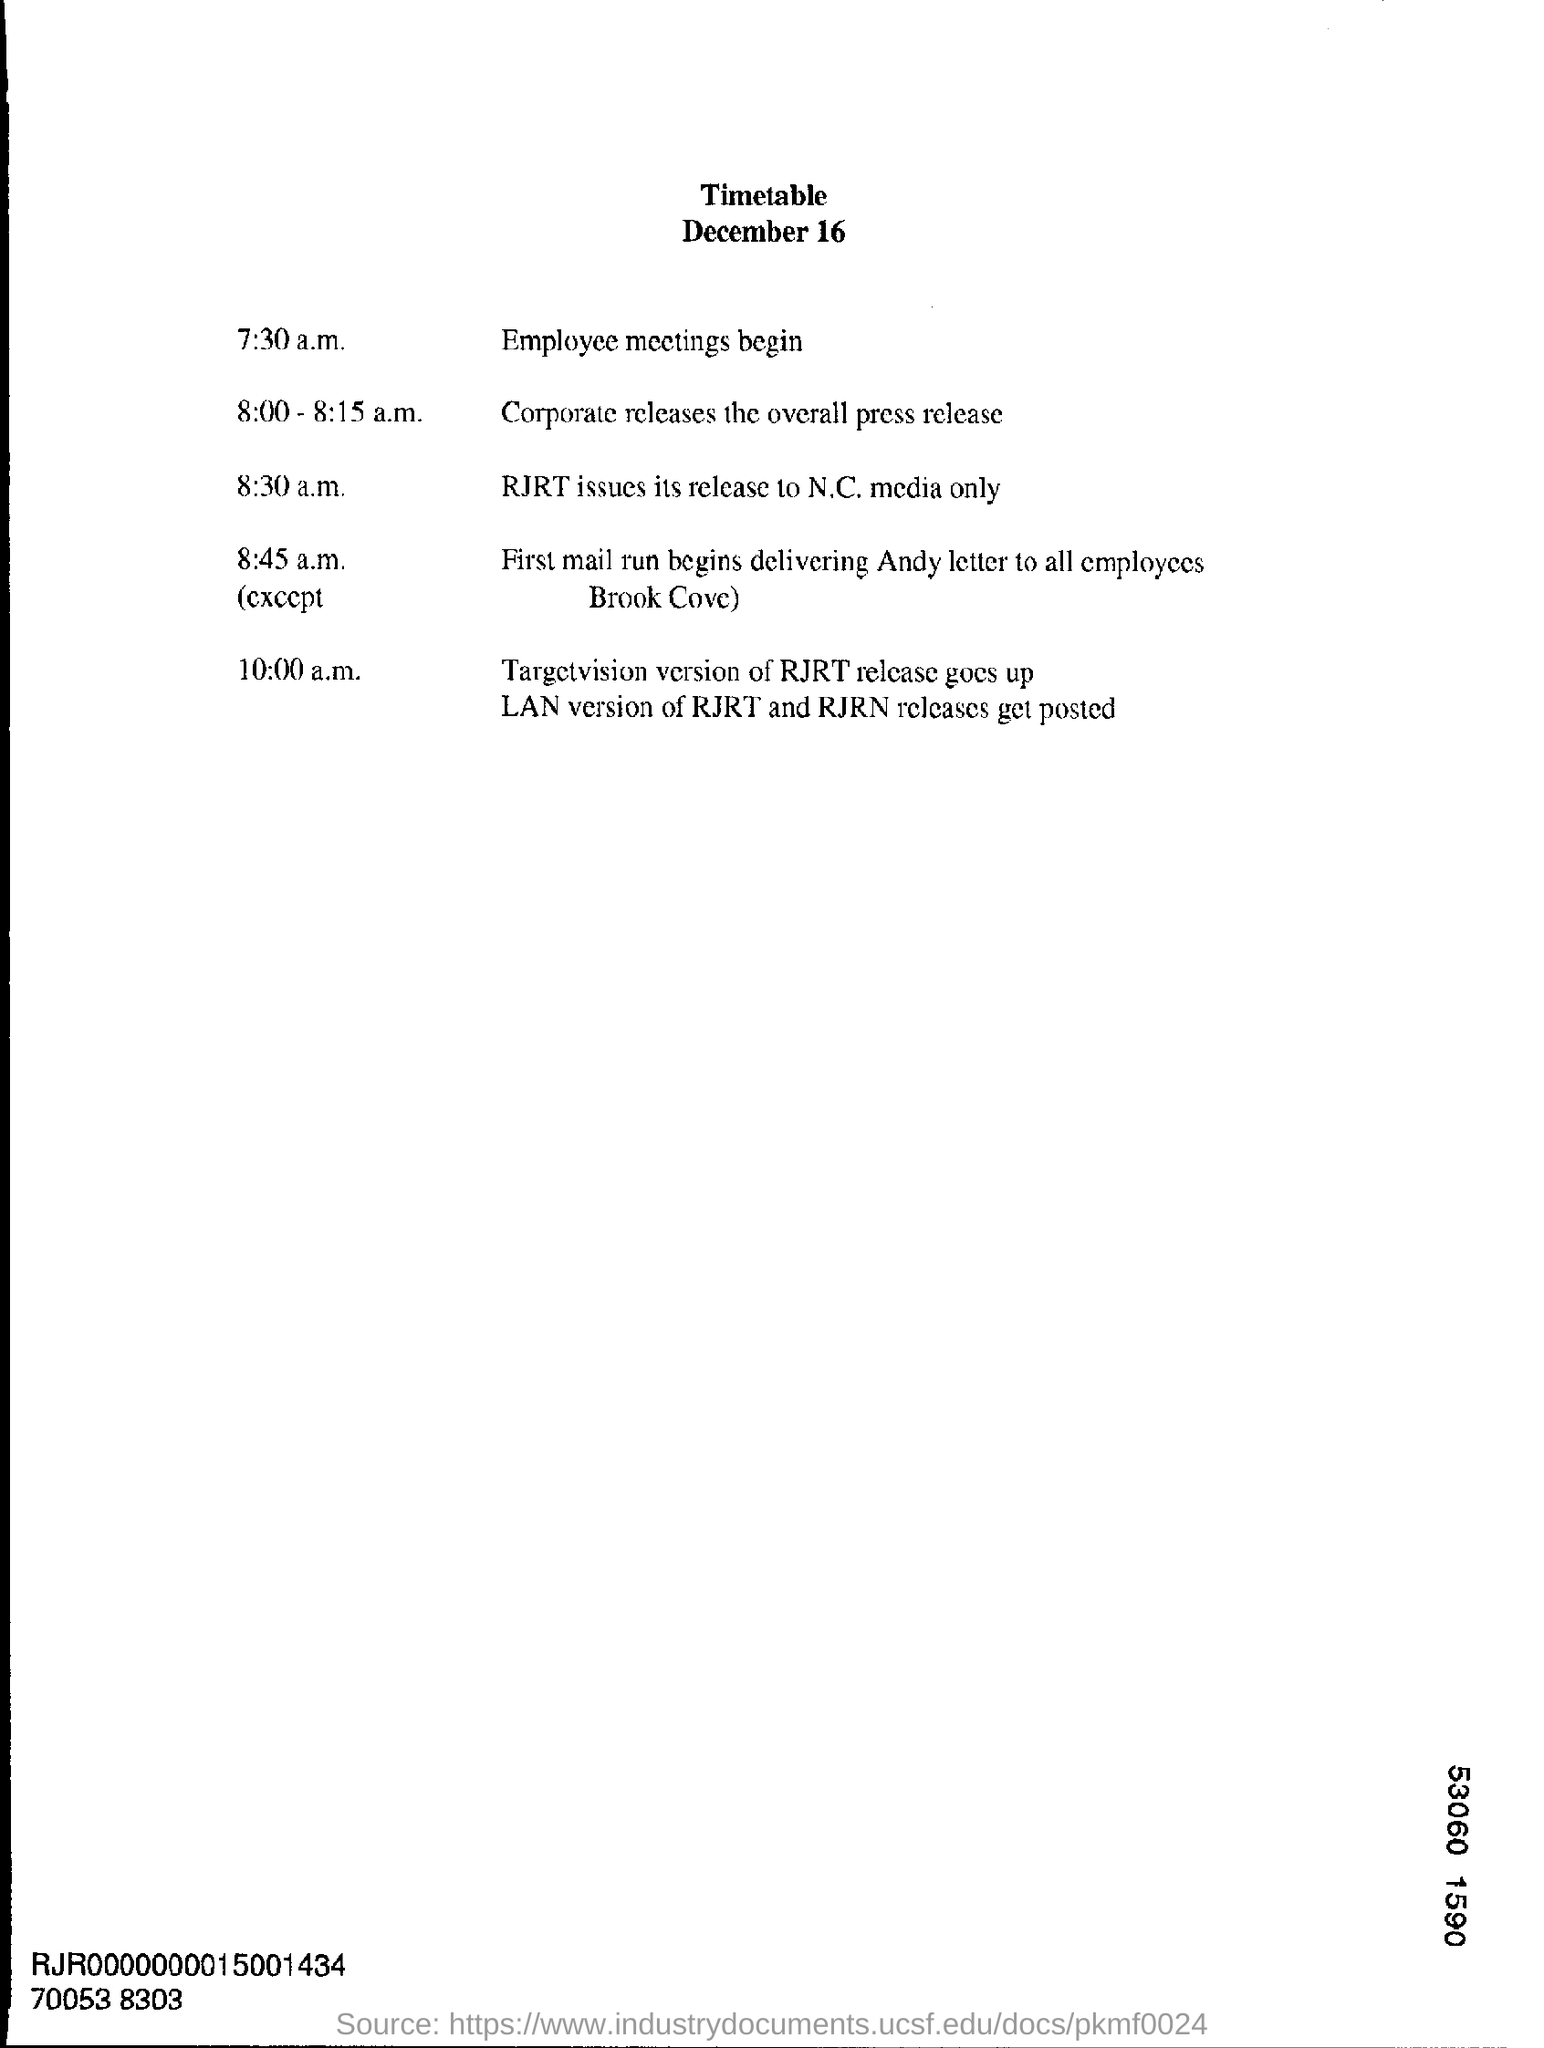What is the heading of the document?
Give a very brief answer. Timetable. What is the date mentioned?
Offer a terse response. December 16. When does the Employee meetings begin?
Your answer should be very brief. 7:30 a.m. 